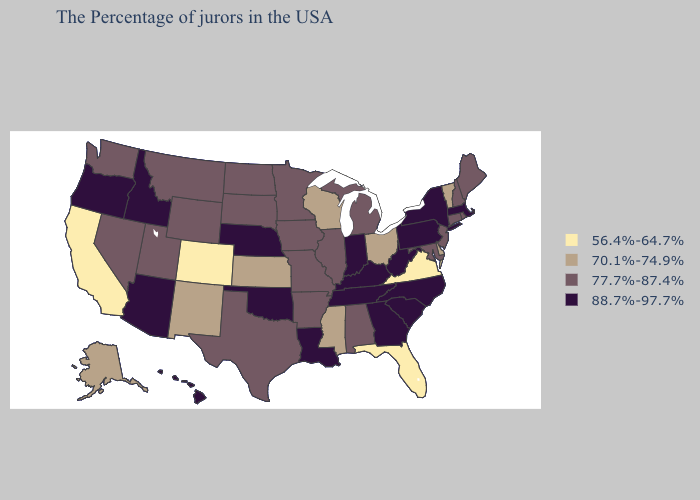What is the highest value in states that border Iowa?
Answer briefly. 88.7%-97.7%. Name the states that have a value in the range 70.1%-74.9%?
Be succinct. Vermont, Delaware, Ohio, Wisconsin, Mississippi, Kansas, New Mexico, Alaska. What is the highest value in the West ?
Be succinct. 88.7%-97.7%. Does Vermont have the lowest value in the Northeast?
Answer briefly. Yes. What is the lowest value in the USA?
Write a very short answer. 56.4%-64.7%. Does Tennessee have the highest value in the USA?
Quick response, please. Yes. Among the states that border Massachusetts , which have the highest value?
Answer briefly. New York. Does Colorado have the lowest value in the USA?
Quick response, please. Yes. Name the states that have a value in the range 77.7%-87.4%?
Concise answer only. Maine, Rhode Island, New Hampshire, Connecticut, New Jersey, Maryland, Michigan, Alabama, Illinois, Missouri, Arkansas, Minnesota, Iowa, Texas, South Dakota, North Dakota, Wyoming, Utah, Montana, Nevada, Washington. Name the states that have a value in the range 77.7%-87.4%?
Give a very brief answer. Maine, Rhode Island, New Hampshire, Connecticut, New Jersey, Maryland, Michigan, Alabama, Illinois, Missouri, Arkansas, Minnesota, Iowa, Texas, South Dakota, North Dakota, Wyoming, Utah, Montana, Nevada, Washington. What is the lowest value in states that border Virginia?
Concise answer only. 77.7%-87.4%. What is the value of Mississippi?
Concise answer only. 70.1%-74.9%. What is the lowest value in the USA?
Short answer required. 56.4%-64.7%. How many symbols are there in the legend?
Short answer required. 4. Is the legend a continuous bar?
Concise answer only. No. 